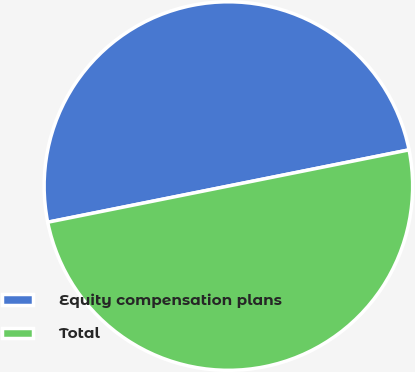Convert chart to OTSL. <chart><loc_0><loc_0><loc_500><loc_500><pie_chart><fcel>Equity compensation plans<fcel>Total<nl><fcel>50.0%<fcel>50.0%<nl></chart> 